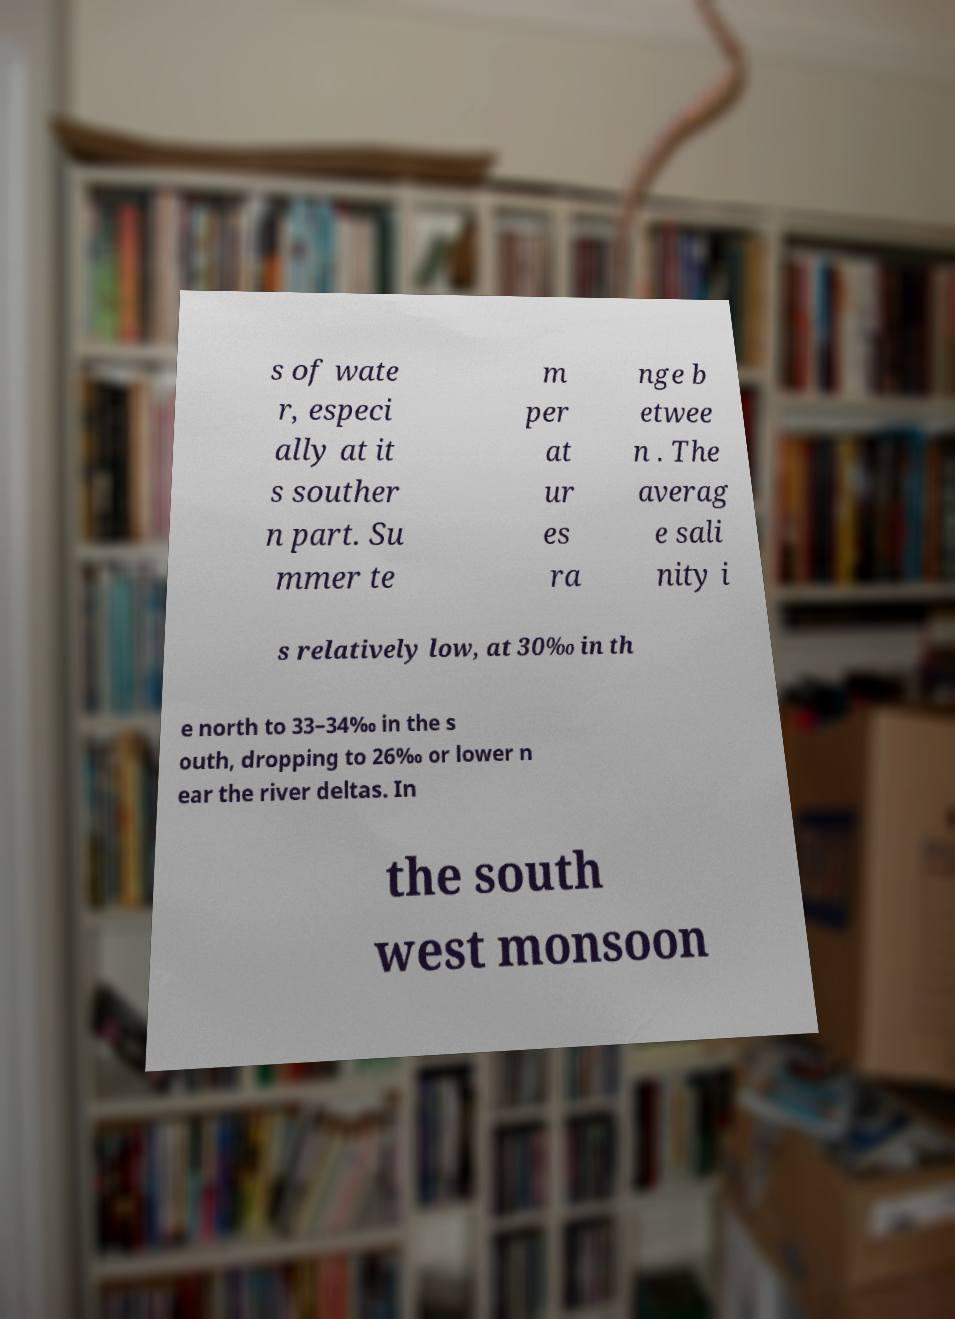Please read and relay the text visible in this image. What does it say? s of wate r, especi ally at it s souther n part. Su mmer te m per at ur es ra nge b etwee n . The averag e sali nity i s relatively low, at 30‰ in th e north to 33–34‰ in the s outh, dropping to 26‰ or lower n ear the river deltas. In the south west monsoon 